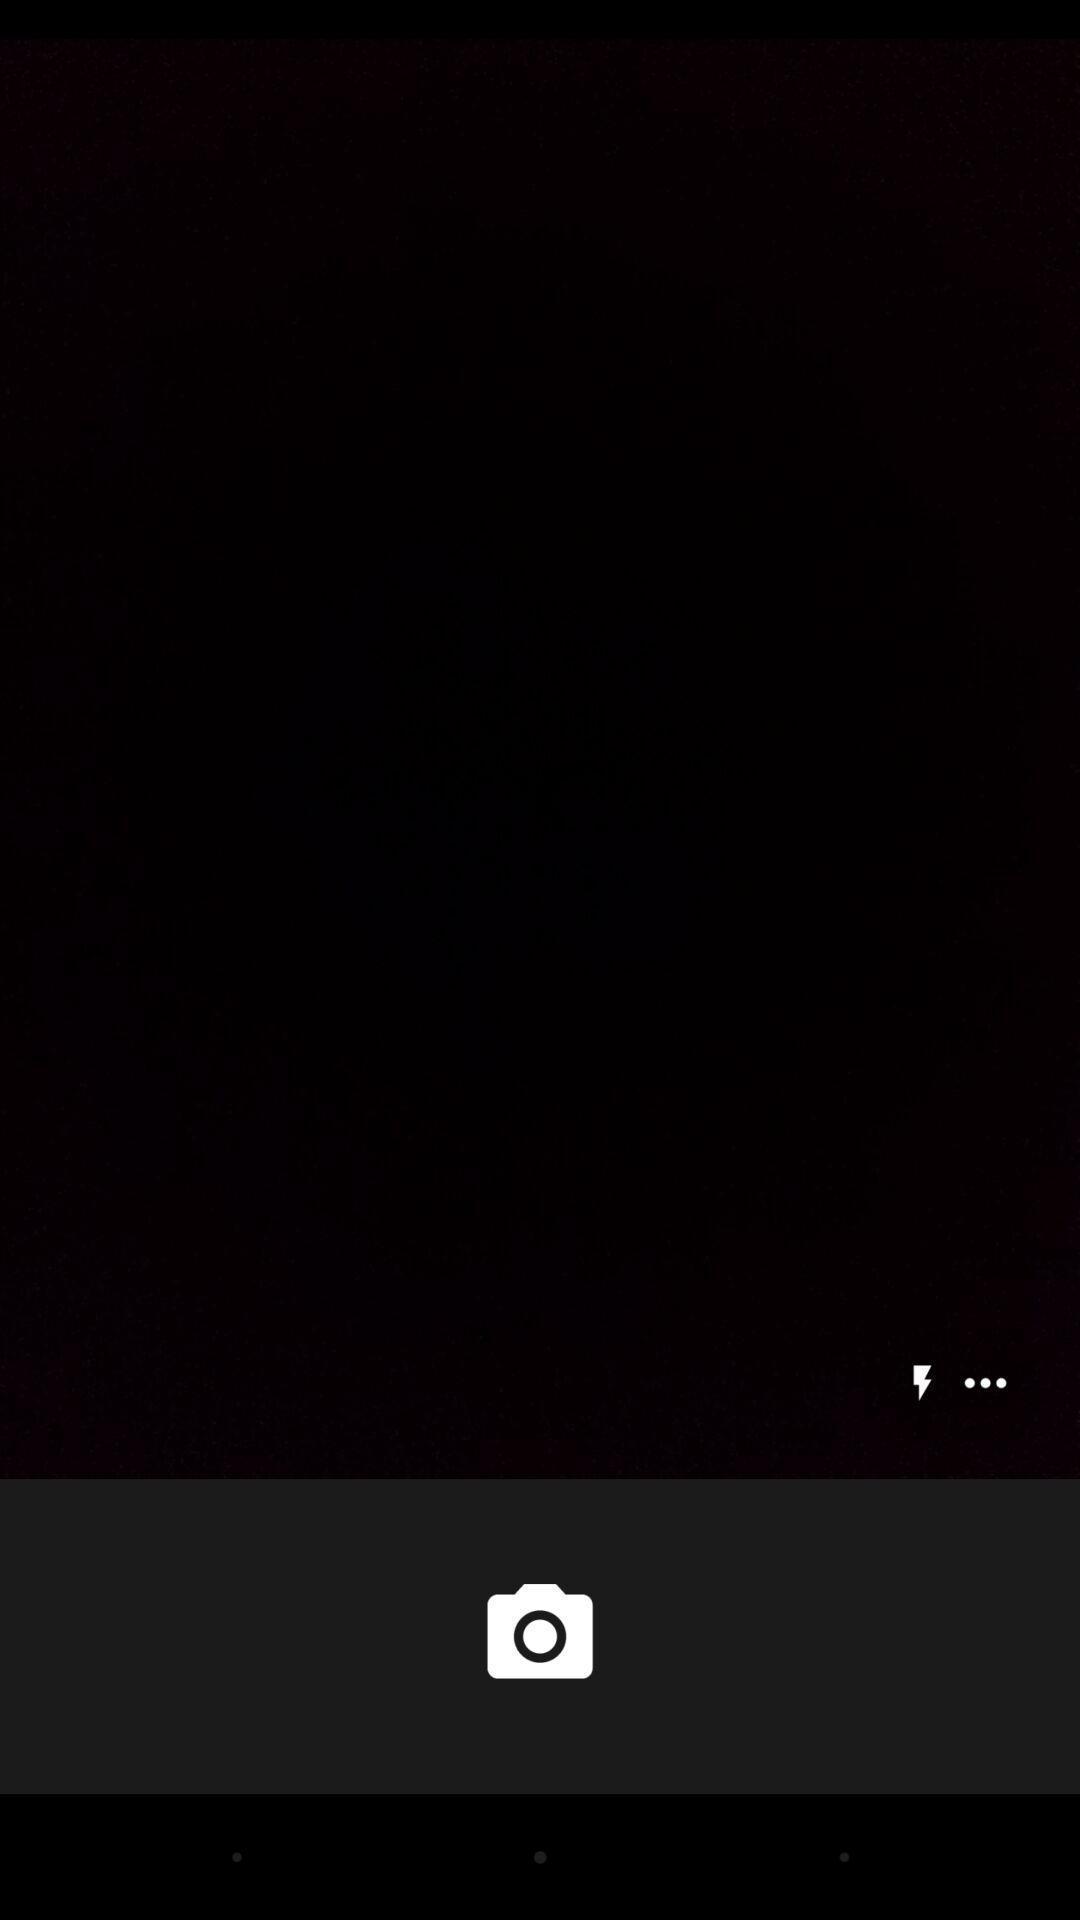Provide a description of this screenshot. Page showing the blank screen in camera app. 